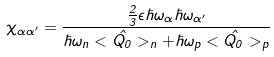Convert formula to latex. <formula><loc_0><loc_0><loc_500><loc_500>\chi _ { \alpha \alpha ^ { \prime } } = { \frac { { \frac { 2 } { 3 } } \epsilon \hbar { \omega } _ { \alpha } \hbar { \omega } _ { \alpha ^ { \prime } } } { \hbar { \omega } _ { n } < \hat { Q _ { 0 } } > _ { n } + \hbar { \omega } _ { p } < \hat { Q _ { 0 } } > _ { p } } }</formula> 